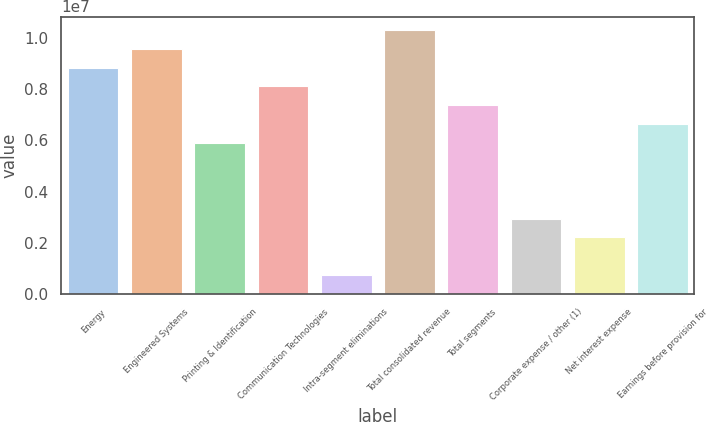Convert chart to OTSL. <chart><loc_0><loc_0><loc_500><loc_500><bar_chart><fcel>Energy<fcel>Engineered Systems<fcel>Printing & Identification<fcel>Communication Technologies<fcel>Intra-segment eliminations<fcel>Total consolidated revenue<fcel>Total segments<fcel>Corporate expense / other (1)<fcel>Net interest expense<fcel>Earnings before provision for<nl><fcel>8.84298e+06<fcel>9.5799e+06<fcel>5.89533e+06<fcel>8.10607e+06<fcel>736931<fcel>1.03168e+07<fcel>7.36915e+06<fcel>2.94767e+06<fcel>2.21076e+06<fcel>6.63224e+06<nl></chart> 